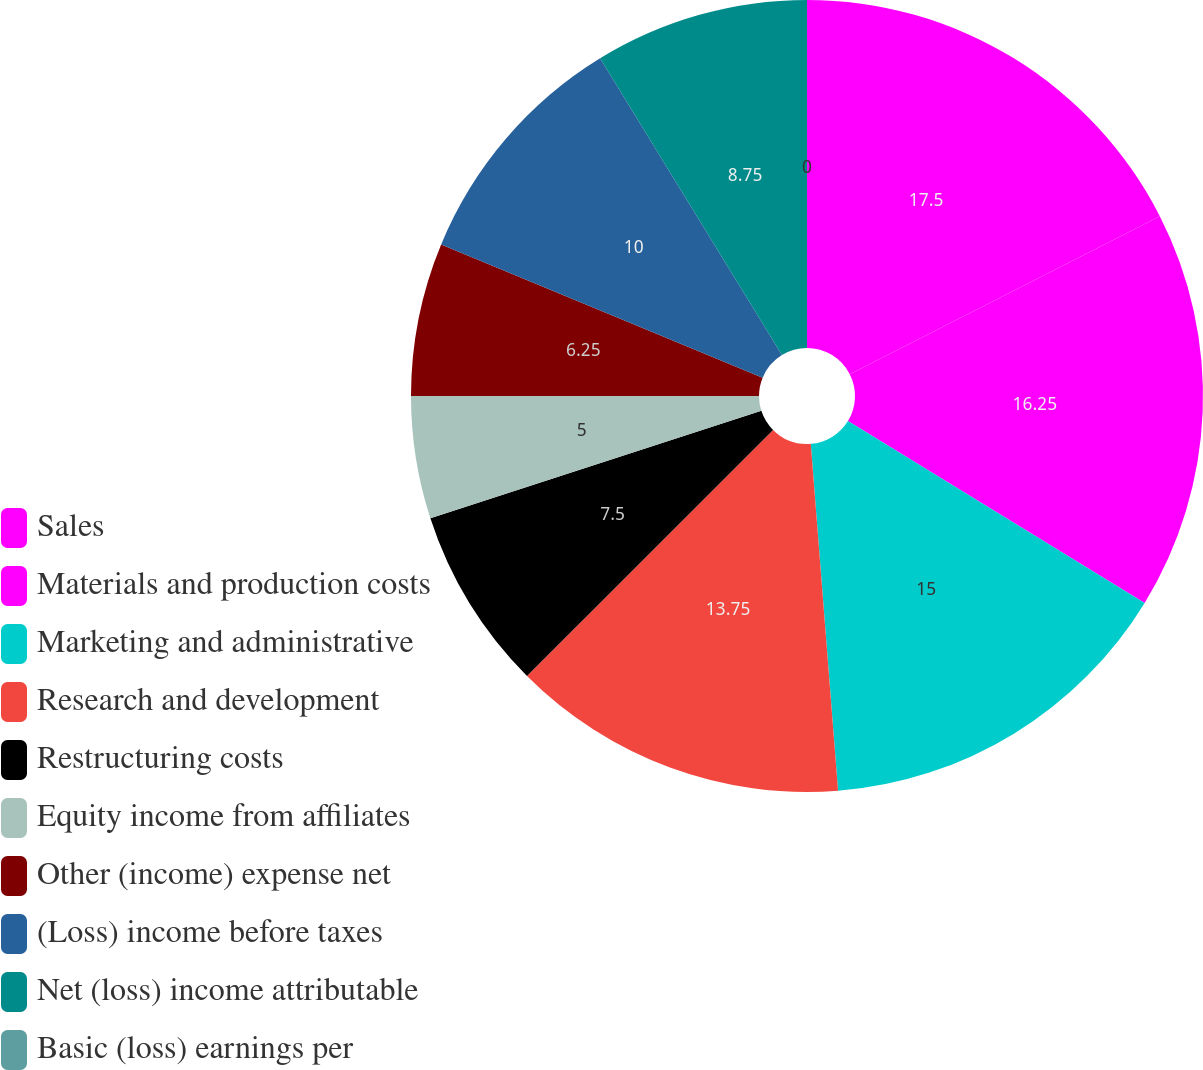<chart> <loc_0><loc_0><loc_500><loc_500><pie_chart><fcel>Sales<fcel>Materials and production costs<fcel>Marketing and administrative<fcel>Research and development<fcel>Restructuring costs<fcel>Equity income from affiliates<fcel>Other (income) expense net<fcel>(Loss) income before taxes<fcel>Net (loss) income attributable<fcel>Basic (loss) earnings per<nl><fcel>17.5%<fcel>16.25%<fcel>15.0%<fcel>13.75%<fcel>7.5%<fcel>5.0%<fcel>6.25%<fcel>10.0%<fcel>8.75%<fcel>0.0%<nl></chart> 